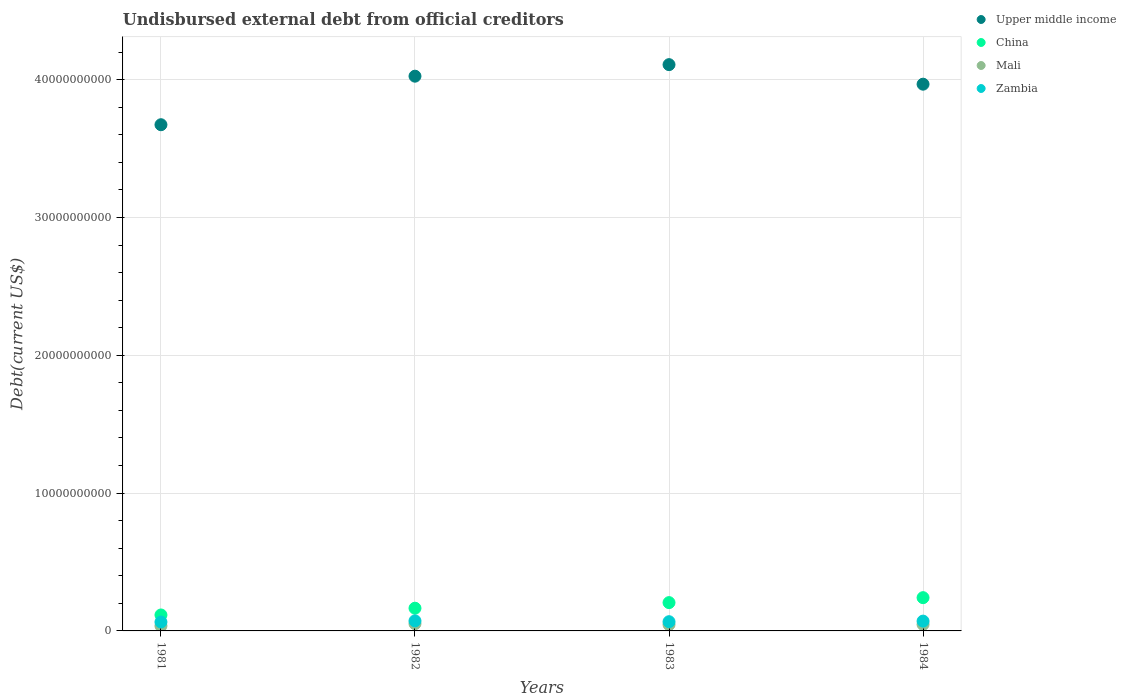Is the number of dotlines equal to the number of legend labels?
Make the answer very short. Yes. What is the total debt in China in 1982?
Offer a very short reply. 1.65e+09. Across all years, what is the maximum total debt in Upper middle income?
Your answer should be compact. 4.11e+1. Across all years, what is the minimum total debt in Mali?
Your answer should be compact. 3.65e+08. In which year was the total debt in Upper middle income maximum?
Offer a terse response. 1983. What is the total total debt in Mali in the graph?
Ensure brevity in your answer.  1.82e+09. What is the difference between the total debt in Zambia in 1982 and that in 1983?
Keep it short and to the point. 5.97e+07. What is the difference between the total debt in China in 1983 and the total debt in Upper middle income in 1981?
Your answer should be very brief. -3.47e+1. What is the average total debt in Upper middle income per year?
Keep it short and to the point. 3.94e+1. In the year 1982, what is the difference between the total debt in Zambia and total debt in China?
Offer a terse response. -9.19e+08. What is the ratio of the total debt in China in 1982 to that in 1983?
Offer a terse response. 0.8. Is the total debt in Upper middle income in 1981 less than that in 1982?
Offer a very short reply. Yes. What is the difference between the highest and the second highest total debt in Mali?
Provide a succinct answer. 5.24e+07. What is the difference between the highest and the lowest total debt in China?
Keep it short and to the point. 1.26e+09. Is the sum of the total debt in Upper middle income in 1981 and 1983 greater than the maximum total debt in China across all years?
Offer a very short reply. Yes. Is it the case that in every year, the sum of the total debt in Zambia and total debt in China  is greater than the sum of total debt in Upper middle income and total debt in Mali?
Your answer should be compact. No. Is it the case that in every year, the sum of the total debt in Mali and total debt in Upper middle income  is greater than the total debt in Zambia?
Your answer should be compact. Yes. Is the total debt in Mali strictly greater than the total debt in China over the years?
Your response must be concise. No. Are the values on the major ticks of Y-axis written in scientific E-notation?
Keep it short and to the point. No. Does the graph contain any zero values?
Your answer should be very brief. No. How are the legend labels stacked?
Your answer should be compact. Vertical. What is the title of the graph?
Provide a short and direct response. Undisbursed external debt from official creditors. What is the label or title of the X-axis?
Keep it short and to the point. Years. What is the label or title of the Y-axis?
Offer a terse response. Debt(current US$). What is the Debt(current US$) in Upper middle income in 1981?
Make the answer very short. 3.67e+1. What is the Debt(current US$) in China in 1981?
Your response must be concise. 1.16e+09. What is the Debt(current US$) in Mali in 1981?
Make the answer very short. 3.65e+08. What is the Debt(current US$) of Zambia in 1981?
Your answer should be compact. 6.46e+08. What is the Debt(current US$) in Upper middle income in 1982?
Offer a terse response. 4.03e+1. What is the Debt(current US$) of China in 1982?
Offer a very short reply. 1.65e+09. What is the Debt(current US$) in Mali in 1982?
Offer a terse response. 5.25e+08. What is the Debt(current US$) of Zambia in 1982?
Your response must be concise. 7.30e+08. What is the Debt(current US$) of Upper middle income in 1983?
Your answer should be very brief. 4.11e+1. What is the Debt(current US$) of China in 1983?
Make the answer very short. 2.05e+09. What is the Debt(current US$) in Mali in 1983?
Make the answer very short. 4.59e+08. What is the Debt(current US$) in Zambia in 1983?
Your answer should be compact. 6.70e+08. What is the Debt(current US$) of Upper middle income in 1984?
Provide a short and direct response. 3.97e+1. What is the Debt(current US$) of China in 1984?
Make the answer very short. 2.41e+09. What is the Debt(current US$) of Mali in 1984?
Your answer should be very brief. 4.72e+08. What is the Debt(current US$) of Zambia in 1984?
Provide a succinct answer. 7.12e+08. Across all years, what is the maximum Debt(current US$) in Upper middle income?
Ensure brevity in your answer.  4.11e+1. Across all years, what is the maximum Debt(current US$) in China?
Make the answer very short. 2.41e+09. Across all years, what is the maximum Debt(current US$) of Mali?
Offer a terse response. 5.25e+08. Across all years, what is the maximum Debt(current US$) of Zambia?
Give a very brief answer. 7.30e+08. Across all years, what is the minimum Debt(current US$) of Upper middle income?
Ensure brevity in your answer.  3.67e+1. Across all years, what is the minimum Debt(current US$) of China?
Your answer should be compact. 1.16e+09. Across all years, what is the minimum Debt(current US$) in Mali?
Your answer should be very brief. 3.65e+08. Across all years, what is the minimum Debt(current US$) of Zambia?
Offer a very short reply. 6.46e+08. What is the total Debt(current US$) of Upper middle income in the graph?
Your answer should be very brief. 1.58e+11. What is the total Debt(current US$) in China in the graph?
Offer a very short reply. 7.27e+09. What is the total Debt(current US$) of Mali in the graph?
Your answer should be very brief. 1.82e+09. What is the total Debt(current US$) of Zambia in the graph?
Offer a terse response. 2.76e+09. What is the difference between the Debt(current US$) in Upper middle income in 1981 and that in 1982?
Provide a short and direct response. -3.52e+09. What is the difference between the Debt(current US$) of China in 1981 and that in 1982?
Ensure brevity in your answer.  -4.90e+08. What is the difference between the Debt(current US$) in Mali in 1981 and that in 1982?
Your answer should be compact. -1.60e+08. What is the difference between the Debt(current US$) in Zambia in 1981 and that in 1982?
Your response must be concise. -8.32e+07. What is the difference between the Debt(current US$) in Upper middle income in 1981 and that in 1983?
Provide a short and direct response. -4.36e+09. What is the difference between the Debt(current US$) of China in 1981 and that in 1983?
Offer a very short reply. -8.96e+08. What is the difference between the Debt(current US$) of Mali in 1981 and that in 1983?
Your answer should be compact. -9.45e+07. What is the difference between the Debt(current US$) of Zambia in 1981 and that in 1983?
Your response must be concise. -2.36e+07. What is the difference between the Debt(current US$) in Upper middle income in 1981 and that in 1984?
Keep it short and to the point. -2.94e+09. What is the difference between the Debt(current US$) in China in 1981 and that in 1984?
Your response must be concise. -1.26e+09. What is the difference between the Debt(current US$) of Mali in 1981 and that in 1984?
Give a very brief answer. -1.08e+08. What is the difference between the Debt(current US$) of Zambia in 1981 and that in 1984?
Offer a terse response. -6.55e+07. What is the difference between the Debt(current US$) of Upper middle income in 1982 and that in 1983?
Your response must be concise. -8.38e+08. What is the difference between the Debt(current US$) in China in 1982 and that in 1983?
Give a very brief answer. -4.06e+08. What is the difference between the Debt(current US$) in Mali in 1982 and that in 1983?
Your answer should be very brief. 6.59e+07. What is the difference between the Debt(current US$) of Zambia in 1982 and that in 1983?
Your answer should be very brief. 5.97e+07. What is the difference between the Debt(current US$) in Upper middle income in 1982 and that in 1984?
Keep it short and to the point. 5.80e+08. What is the difference between the Debt(current US$) in China in 1982 and that in 1984?
Ensure brevity in your answer.  -7.65e+08. What is the difference between the Debt(current US$) in Mali in 1982 and that in 1984?
Offer a very short reply. 5.24e+07. What is the difference between the Debt(current US$) of Zambia in 1982 and that in 1984?
Your answer should be very brief. 1.78e+07. What is the difference between the Debt(current US$) in Upper middle income in 1983 and that in 1984?
Your answer should be compact. 1.42e+09. What is the difference between the Debt(current US$) of China in 1983 and that in 1984?
Make the answer very short. -3.60e+08. What is the difference between the Debt(current US$) of Mali in 1983 and that in 1984?
Your response must be concise. -1.34e+07. What is the difference between the Debt(current US$) of Zambia in 1983 and that in 1984?
Provide a short and direct response. -4.19e+07. What is the difference between the Debt(current US$) in Upper middle income in 1981 and the Debt(current US$) in China in 1982?
Provide a short and direct response. 3.51e+1. What is the difference between the Debt(current US$) in Upper middle income in 1981 and the Debt(current US$) in Mali in 1982?
Your answer should be very brief. 3.62e+1. What is the difference between the Debt(current US$) of Upper middle income in 1981 and the Debt(current US$) of Zambia in 1982?
Provide a short and direct response. 3.60e+1. What is the difference between the Debt(current US$) of China in 1981 and the Debt(current US$) of Mali in 1982?
Your answer should be very brief. 6.33e+08. What is the difference between the Debt(current US$) in China in 1981 and the Debt(current US$) in Zambia in 1982?
Give a very brief answer. 4.28e+08. What is the difference between the Debt(current US$) of Mali in 1981 and the Debt(current US$) of Zambia in 1982?
Ensure brevity in your answer.  -3.65e+08. What is the difference between the Debt(current US$) in Upper middle income in 1981 and the Debt(current US$) in China in 1983?
Ensure brevity in your answer.  3.47e+1. What is the difference between the Debt(current US$) of Upper middle income in 1981 and the Debt(current US$) of Mali in 1983?
Offer a very short reply. 3.63e+1. What is the difference between the Debt(current US$) in Upper middle income in 1981 and the Debt(current US$) in Zambia in 1983?
Ensure brevity in your answer.  3.61e+1. What is the difference between the Debt(current US$) in China in 1981 and the Debt(current US$) in Mali in 1983?
Keep it short and to the point. 6.99e+08. What is the difference between the Debt(current US$) of China in 1981 and the Debt(current US$) of Zambia in 1983?
Your answer should be very brief. 4.88e+08. What is the difference between the Debt(current US$) in Mali in 1981 and the Debt(current US$) in Zambia in 1983?
Your answer should be very brief. -3.05e+08. What is the difference between the Debt(current US$) of Upper middle income in 1981 and the Debt(current US$) of China in 1984?
Offer a terse response. 3.43e+1. What is the difference between the Debt(current US$) of Upper middle income in 1981 and the Debt(current US$) of Mali in 1984?
Provide a short and direct response. 3.63e+1. What is the difference between the Debt(current US$) in Upper middle income in 1981 and the Debt(current US$) in Zambia in 1984?
Your response must be concise. 3.60e+1. What is the difference between the Debt(current US$) in China in 1981 and the Debt(current US$) in Mali in 1984?
Give a very brief answer. 6.85e+08. What is the difference between the Debt(current US$) of China in 1981 and the Debt(current US$) of Zambia in 1984?
Provide a succinct answer. 4.46e+08. What is the difference between the Debt(current US$) of Mali in 1981 and the Debt(current US$) of Zambia in 1984?
Ensure brevity in your answer.  -3.47e+08. What is the difference between the Debt(current US$) of Upper middle income in 1982 and the Debt(current US$) of China in 1983?
Offer a very short reply. 3.82e+1. What is the difference between the Debt(current US$) of Upper middle income in 1982 and the Debt(current US$) of Mali in 1983?
Offer a terse response. 3.98e+1. What is the difference between the Debt(current US$) of Upper middle income in 1982 and the Debt(current US$) of Zambia in 1983?
Give a very brief answer. 3.96e+1. What is the difference between the Debt(current US$) in China in 1982 and the Debt(current US$) in Mali in 1983?
Provide a succinct answer. 1.19e+09. What is the difference between the Debt(current US$) of China in 1982 and the Debt(current US$) of Zambia in 1983?
Keep it short and to the point. 9.78e+08. What is the difference between the Debt(current US$) in Mali in 1982 and the Debt(current US$) in Zambia in 1983?
Ensure brevity in your answer.  -1.45e+08. What is the difference between the Debt(current US$) in Upper middle income in 1982 and the Debt(current US$) in China in 1984?
Your answer should be very brief. 3.78e+1. What is the difference between the Debt(current US$) of Upper middle income in 1982 and the Debt(current US$) of Mali in 1984?
Provide a short and direct response. 3.98e+1. What is the difference between the Debt(current US$) of Upper middle income in 1982 and the Debt(current US$) of Zambia in 1984?
Ensure brevity in your answer.  3.95e+1. What is the difference between the Debt(current US$) in China in 1982 and the Debt(current US$) in Mali in 1984?
Make the answer very short. 1.18e+09. What is the difference between the Debt(current US$) in China in 1982 and the Debt(current US$) in Zambia in 1984?
Give a very brief answer. 9.36e+08. What is the difference between the Debt(current US$) of Mali in 1982 and the Debt(current US$) of Zambia in 1984?
Your response must be concise. -1.87e+08. What is the difference between the Debt(current US$) in Upper middle income in 1983 and the Debt(current US$) in China in 1984?
Provide a short and direct response. 3.87e+1. What is the difference between the Debt(current US$) of Upper middle income in 1983 and the Debt(current US$) of Mali in 1984?
Make the answer very short. 4.06e+1. What is the difference between the Debt(current US$) in Upper middle income in 1983 and the Debt(current US$) in Zambia in 1984?
Offer a terse response. 4.04e+1. What is the difference between the Debt(current US$) in China in 1983 and the Debt(current US$) in Mali in 1984?
Your response must be concise. 1.58e+09. What is the difference between the Debt(current US$) of China in 1983 and the Debt(current US$) of Zambia in 1984?
Your response must be concise. 1.34e+09. What is the difference between the Debt(current US$) in Mali in 1983 and the Debt(current US$) in Zambia in 1984?
Provide a short and direct response. -2.53e+08. What is the average Debt(current US$) of Upper middle income per year?
Your answer should be compact. 3.94e+1. What is the average Debt(current US$) in China per year?
Provide a short and direct response. 1.82e+09. What is the average Debt(current US$) in Mali per year?
Your answer should be compact. 4.55e+08. What is the average Debt(current US$) in Zambia per year?
Offer a terse response. 6.90e+08. In the year 1981, what is the difference between the Debt(current US$) of Upper middle income and Debt(current US$) of China?
Keep it short and to the point. 3.56e+1. In the year 1981, what is the difference between the Debt(current US$) in Upper middle income and Debt(current US$) in Mali?
Your answer should be very brief. 3.64e+1. In the year 1981, what is the difference between the Debt(current US$) in Upper middle income and Debt(current US$) in Zambia?
Your response must be concise. 3.61e+1. In the year 1981, what is the difference between the Debt(current US$) in China and Debt(current US$) in Mali?
Your response must be concise. 7.93e+08. In the year 1981, what is the difference between the Debt(current US$) in China and Debt(current US$) in Zambia?
Make the answer very short. 5.11e+08. In the year 1981, what is the difference between the Debt(current US$) in Mali and Debt(current US$) in Zambia?
Offer a very short reply. -2.82e+08. In the year 1982, what is the difference between the Debt(current US$) in Upper middle income and Debt(current US$) in China?
Your answer should be compact. 3.86e+1. In the year 1982, what is the difference between the Debt(current US$) in Upper middle income and Debt(current US$) in Mali?
Ensure brevity in your answer.  3.97e+1. In the year 1982, what is the difference between the Debt(current US$) of Upper middle income and Debt(current US$) of Zambia?
Your answer should be compact. 3.95e+1. In the year 1982, what is the difference between the Debt(current US$) in China and Debt(current US$) in Mali?
Your answer should be compact. 1.12e+09. In the year 1982, what is the difference between the Debt(current US$) of China and Debt(current US$) of Zambia?
Offer a terse response. 9.19e+08. In the year 1982, what is the difference between the Debt(current US$) in Mali and Debt(current US$) in Zambia?
Provide a succinct answer. -2.05e+08. In the year 1983, what is the difference between the Debt(current US$) of Upper middle income and Debt(current US$) of China?
Offer a very short reply. 3.90e+1. In the year 1983, what is the difference between the Debt(current US$) in Upper middle income and Debt(current US$) in Mali?
Keep it short and to the point. 4.06e+1. In the year 1983, what is the difference between the Debt(current US$) in Upper middle income and Debt(current US$) in Zambia?
Your answer should be compact. 4.04e+1. In the year 1983, what is the difference between the Debt(current US$) in China and Debt(current US$) in Mali?
Offer a terse response. 1.60e+09. In the year 1983, what is the difference between the Debt(current US$) of China and Debt(current US$) of Zambia?
Make the answer very short. 1.38e+09. In the year 1983, what is the difference between the Debt(current US$) of Mali and Debt(current US$) of Zambia?
Ensure brevity in your answer.  -2.11e+08. In the year 1984, what is the difference between the Debt(current US$) of Upper middle income and Debt(current US$) of China?
Give a very brief answer. 3.73e+1. In the year 1984, what is the difference between the Debt(current US$) in Upper middle income and Debt(current US$) in Mali?
Make the answer very short. 3.92e+1. In the year 1984, what is the difference between the Debt(current US$) in Upper middle income and Debt(current US$) in Zambia?
Offer a terse response. 3.90e+1. In the year 1984, what is the difference between the Debt(current US$) in China and Debt(current US$) in Mali?
Offer a very short reply. 1.94e+09. In the year 1984, what is the difference between the Debt(current US$) of China and Debt(current US$) of Zambia?
Your answer should be compact. 1.70e+09. In the year 1984, what is the difference between the Debt(current US$) of Mali and Debt(current US$) of Zambia?
Your answer should be compact. -2.40e+08. What is the ratio of the Debt(current US$) in Upper middle income in 1981 to that in 1982?
Provide a short and direct response. 0.91. What is the ratio of the Debt(current US$) of China in 1981 to that in 1982?
Keep it short and to the point. 0.7. What is the ratio of the Debt(current US$) in Mali in 1981 to that in 1982?
Provide a succinct answer. 0.69. What is the ratio of the Debt(current US$) of Zambia in 1981 to that in 1982?
Offer a terse response. 0.89. What is the ratio of the Debt(current US$) in Upper middle income in 1981 to that in 1983?
Your answer should be compact. 0.89. What is the ratio of the Debt(current US$) of China in 1981 to that in 1983?
Offer a very short reply. 0.56. What is the ratio of the Debt(current US$) of Mali in 1981 to that in 1983?
Ensure brevity in your answer.  0.79. What is the ratio of the Debt(current US$) in Zambia in 1981 to that in 1983?
Your response must be concise. 0.96. What is the ratio of the Debt(current US$) in Upper middle income in 1981 to that in 1984?
Offer a very short reply. 0.93. What is the ratio of the Debt(current US$) in China in 1981 to that in 1984?
Offer a terse response. 0.48. What is the ratio of the Debt(current US$) of Mali in 1981 to that in 1984?
Ensure brevity in your answer.  0.77. What is the ratio of the Debt(current US$) in Zambia in 1981 to that in 1984?
Offer a very short reply. 0.91. What is the ratio of the Debt(current US$) in Upper middle income in 1982 to that in 1983?
Keep it short and to the point. 0.98. What is the ratio of the Debt(current US$) of China in 1982 to that in 1983?
Ensure brevity in your answer.  0.8. What is the ratio of the Debt(current US$) in Mali in 1982 to that in 1983?
Offer a terse response. 1.14. What is the ratio of the Debt(current US$) of Zambia in 1982 to that in 1983?
Give a very brief answer. 1.09. What is the ratio of the Debt(current US$) of Upper middle income in 1982 to that in 1984?
Offer a terse response. 1.01. What is the ratio of the Debt(current US$) of China in 1982 to that in 1984?
Keep it short and to the point. 0.68. What is the ratio of the Debt(current US$) of Mali in 1982 to that in 1984?
Give a very brief answer. 1.11. What is the ratio of the Debt(current US$) in Zambia in 1982 to that in 1984?
Your answer should be compact. 1.02. What is the ratio of the Debt(current US$) in Upper middle income in 1983 to that in 1984?
Give a very brief answer. 1.04. What is the ratio of the Debt(current US$) of China in 1983 to that in 1984?
Offer a very short reply. 0.85. What is the ratio of the Debt(current US$) in Mali in 1983 to that in 1984?
Provide a short and direct response. 0.97. What is the difference between the highest and the second highest Debt(current US$) in Upper middle income?
Offer a terse response. 8.38e+08. What is the difference between the highest and the second highest Debt(current US$) in China?
Provide a short and direct response. 3.60e+08. What is the difference between the highest and the second highest Debt(current US$) of Mali?
Make the answer very short. 5.24e+07. What is the difference between the highest and the second highest Debt(current US$) in Zambia?
Make the answer very short. 1.78e+07. What is the difference between the highest and the lowest Debt(current US$) in Upper middle income?
Provide a succinct answer. 4.36e+09. What is the difference between the highest and the lowest Debt(current US$) of China?
Give a very brief answer. 1.26e+09. What is the difference between the highest and the lowest Debt(current US$) of Mali?
Your answer should be very brief. 1.60e+08. What is the difference between the highest and the lowest Debt(current US$) of Zambia?
Keep it short and to the point. 8.32e+07. 